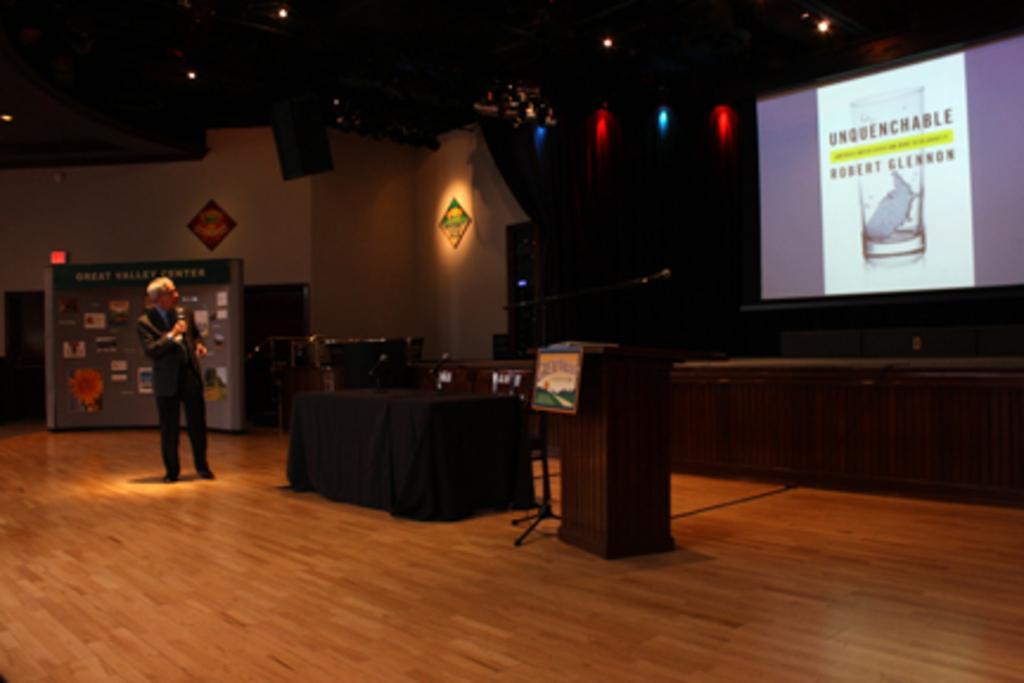Can you describe this image briefly? On the left side of the image we can see person standing on the dais and holding mic. In the center of the image we can see table and cloth. On the right side of the image we can see screen, table and desk. In the background we can see photos attached to the wall, photo frames, light, speaker and wall. 